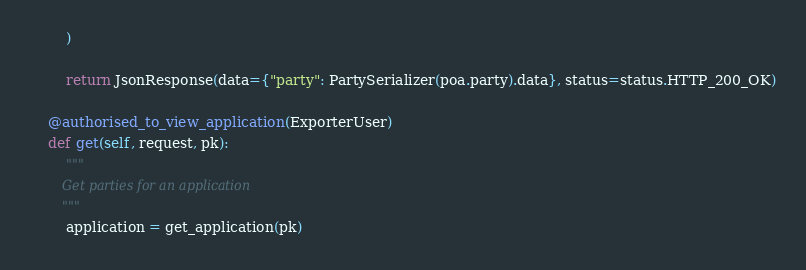Convert code to text. <code><loc_0><loc_0><loc_500><loc_500><_Python_>        )

        return JsonResponse(data={"party": PartySerializer(poa.party).data}, status=status.HTTP_200_OK)

    @authorised_to_view_application(ExporterUser)
    def get(self, request, pk):
        """
        Get parties for an application
        """
        application = get_application(pk)
</code> 